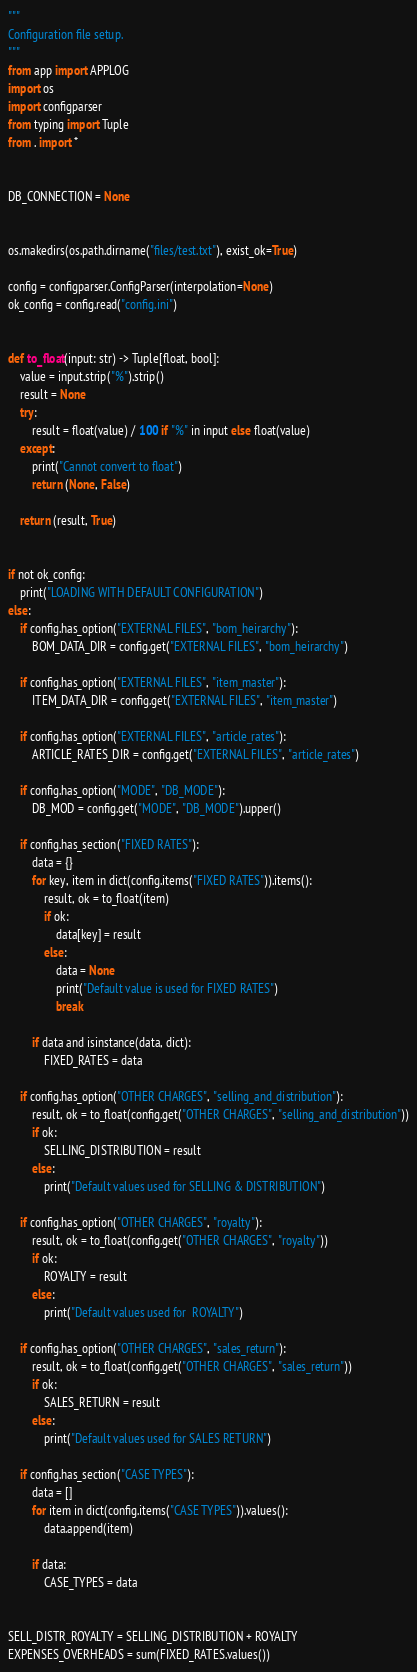Convert code to text. <code><loc_0><loc_0><loc_500><loc_500><_Python_>"""
Configuration file setup.
"""
from app import APPLOG
import os
import configparser
from typing import Tuple
from . import *


DB_CONNECTION = None


os.makedirs(os.path.dirname("files/test.txt"), exist_ok=True)

config = configparser.ConfigParser(interpolation=None)
ok_config = config.read("config.ini")


def to_float(input: str) -> Tuple[float, bool]:
    value = input.strip("%").strip()
    result = None
    try:
        result = float(value) / 100 if "%" in input else float(value)
    except:
        print("Cannot convert to float")
        return (None, False)

    return (result, True)


if not ok_config:
    print("LOADING WITH DEFAULT CONFIGURATION")
else:
    if config.has_option("EXTERNAL FILES", "bom_heirarchy"):
        BOM_DATA_DIR = config.get("EXTERNAL FILES", "bom_heirarchy")

    if config.has_option("EXTERNAL FILES", "item_master"):
        ITEM_DATA_DIR = config.get("EXTERNAL FILES", "item_master")

    if config.has_option("EXTERNAL FILES", "article_rates"):
        ARTICLE_RATES_DIR = config.get("EXTERNAL FILES", "article_rates")

    if config.has_option("MODE", "DB_MODE"):
        DB_MOD = config.get("MODE", "DB_MODE").upper()

    if config.has_section("FIXED RATES"):
        data = {}
        for key, item in dict(config.items("FIXED RATES")).items():
            result, ok = to_float(item)
            if ok:
                data[key] = result
            else:
                data = None
                print("Default value is used for FIXED RATES")
                break

        if data and isinstance(data, dict):
            FIXED_RATES = data

    if config.has_option("OTHER CHARGES", "selling_and_distribution"):
        result, ok = to_float(config.get("OTHER CHARGES", "selling_and_distribution"))
        if ok:
            SELLING_DISTRIBUTION = result
        else:
            print("Default values used for SELLING & DISTRIBUTION")

    if config.has_option("OTHER CHARGES", "royalty"):
        result, ok = to_float(config.get("OTHER CHARGES", "royalty"))
        if ok:
            ROYALTY = result
        else:
            print("Default values used for  ROYALTY")

    if config.has_option("OTHER CHARGES", "sales_return"):
        result, ok = to_float(config.get("OTHER CHARGES", "sales_return"))
        if ok:
            SALES_RETURN = result
        else:
            print("Default values used for SALES RETURN")

    if config.has_section("CASE TYPES"):
        data = []
        for item in dict(config.items("CASE TYPES")).values():
            data.append(item)

        if data:
            CASE_TYPES = data


SELL_DISTR_ROYALTY = SELLING_DISTRIBUTION + ROYALTY
EXPENSES_OVERHEADS = sum(FIXED_RATES.values())
</code> 